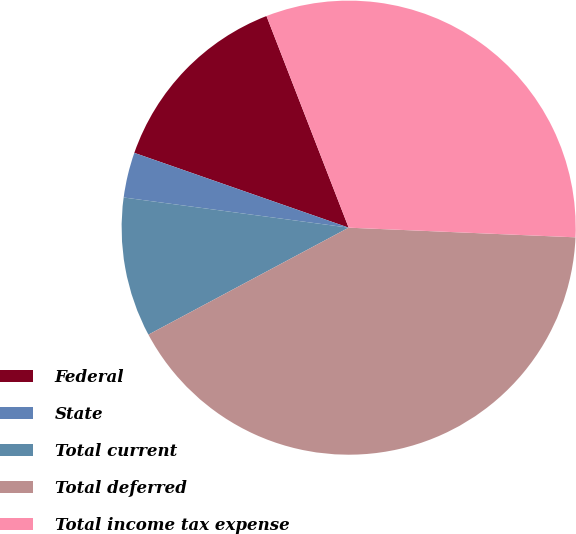Convert chart. <chart><loc_0><loc_0><loc_500><loc_500><pie_chart><fcel>Federal<fcel>State<fcel>Total current<fcel>Total deferred<fcel>Total income tax expense<nl><fcel>13.76%<fcel>3.22%<fcel>9.93%<fcel>41.51%<fcel>31.57%<nl></chart> 